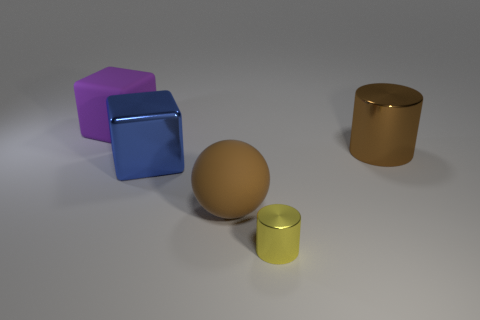Add 4 tiny metal cylinders. How many objects exist? 9 Subtract all spheres. How many objects are left? 4 Subtract all big red metallic things. Subtract all yellow shiny cylinders. How many objects are left? 4 Add 3 tiny yellow metallic cylinders. How many tiny yellow metallic cylinders are left? 4 Add 1 small metallic objects. How many small metallic objects exist? 2 Subtract 0 red cylinders. How many objects are left? 5 